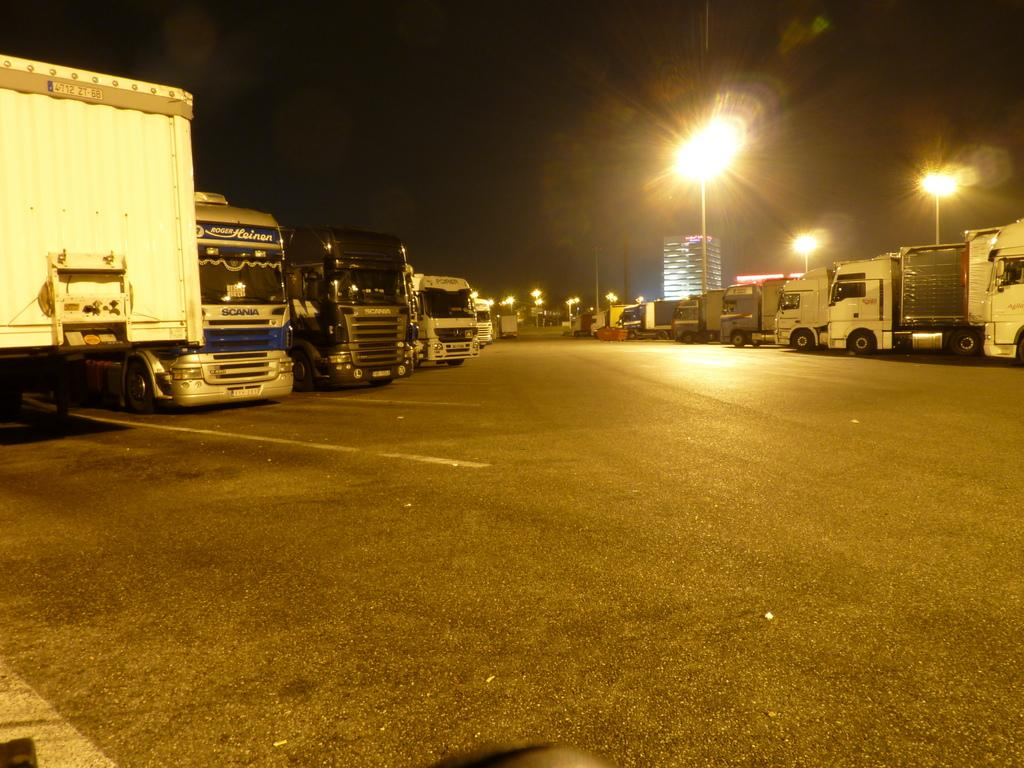What can be seen on the road in the image? There are vehicles on the road in the image. What type of structures are visible in the image? There are buildings in the image. What are the poles with lights used for in the image? The poles with lights are likely used for illumination at night. Can you describe any other objects in the image? There are some objects in the image, but their specific nature is not mentioned in the facts. How would you describe the overall appearance of the image? The background of the image is dark. What type of bird can be seen perched on the government building in the image? There is no bird or government building mentioned in the image. What is the interest rate for the loan depicted in the image? There is no loan or interest rate mentioned in the image. 